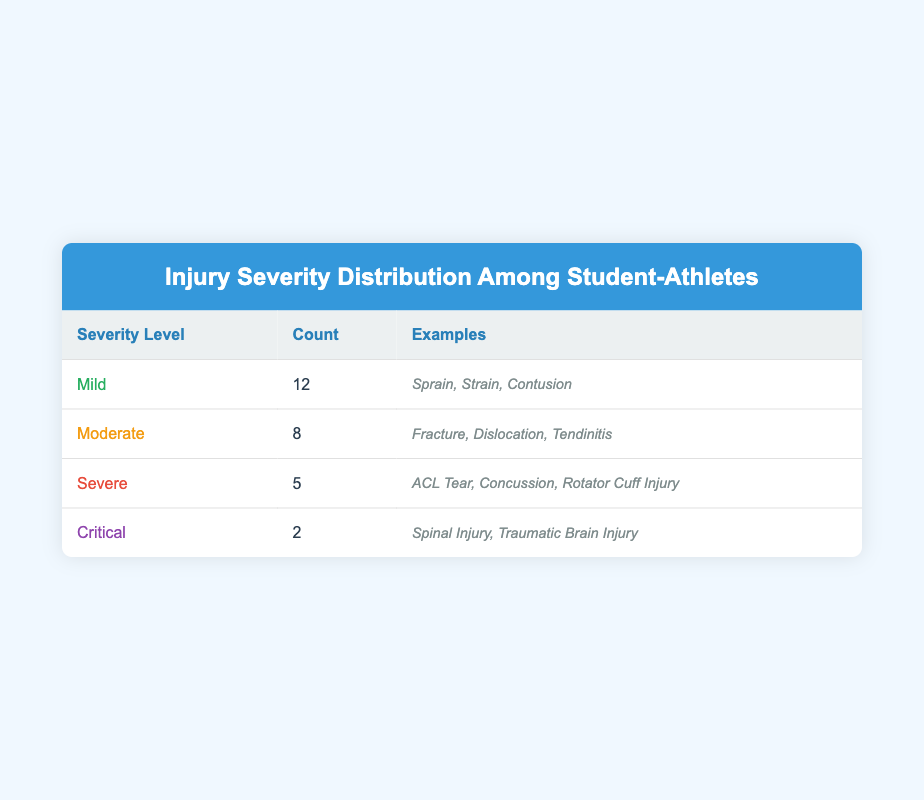What is the count of mild injuries? The count of mild injuries is listed directly in the table under the "Count" column next to the "Mild" severity level. It states that there are 12 mild injuries.
Answer: 12 How many total injuries are categorized as moderate? From the table, the count of moderate injuries is found under the "Count" column next to the "Moderate" severity level, which is 8.
Answer: 8 What is the difference in the number of severe and critical injuries? The count of severe injuries is 5 and the count of critical injuries is 2. To find the difference, subtract the count of critical injuries from the severe injuries: 5 - 2 = 3.
Answer: 3 Are there more mild injuries than critical injuries? The count of mild injuries is 12, and the count of critical injuries is 2. Since 12 is greater than 2, it is true that there are more mild injuries than critical injuries.
Answer: Yes What is the total count of all injuries across all severity levels? To find the total count, sum the counts from each severity level. Mild (12) + Moderate (8) + Severe (5) + Critical (2) = 27.
Answer: 27 How many injuries are categorized as severe? From the table, severe injuries are listed under the "Count" column next to the "Severe" severity level, which indicates there are 5 injuries.
Answer: 5 Is the number of moderate injuries less than the number of mild injuries? The count of moderate injuries is 8 and the count of mild injuries is 12. Since 8 is less than 12, the statement is true.
Answer: Yes If you combine the counts of mild and moderate injuries, what is the resulting total? The count of mild injuries is 12 and the count of moderate injuries is 8. Combining these gives: 12 + 8 = 20.
Answer: 20 What percentage of the total injuries are classified as severe? First, determine the total number of injuries, which is 27. The count of severe injuries is 5. The percentage is calculated as (5/27) * 100 ≈ 18.52%.
Answer: Approximately 18.52% 